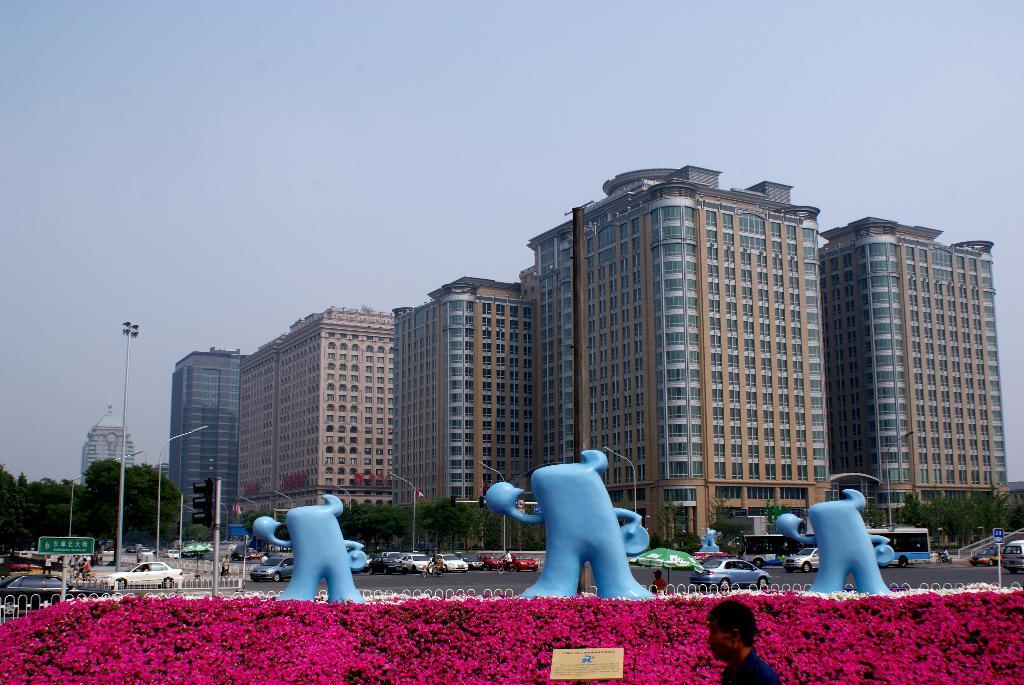In one or two sentences, can you explain what this image depicts? In this picture I can see at the bottom there is a man and it looks like there are flowers. In the middle there are statues, few vehicles are moving on the road. In the background there are trees and buildings, at the top there is the sky. 